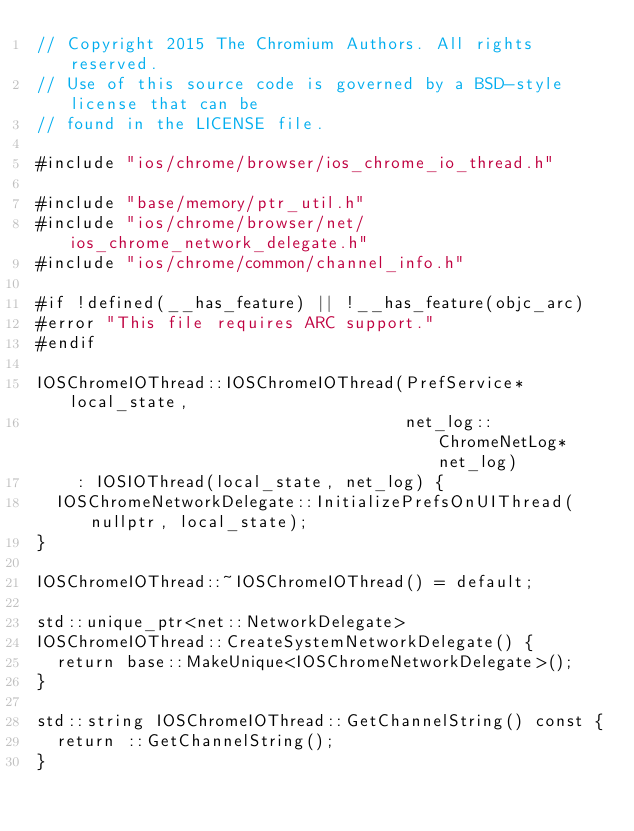<code> <loc_0><loc_0><loc_500><loc_500><_ObjectiveC_>// Copyright 2015 The Chromium Authors. All rights reserved.
// Use of this source code is governed by a BSD-style license that can be
// found in the LICENSE file.

#include "ios/chrome/browser/ios_chrome_io_thread.h"

#include "base/memory/ptr_util.h"
#include "ios/chrome/browser/net/ios_chrome_network_delegate.h"
#include "ios/chrome/common/channel_info.h"

#if !defined(__has_feature) || !__has_feature(objc_arc)
#error "This file requires ARC support."
#endif

IOSChromeIOThread::IOSChromeIOThread(PrefService* local_state,
                                     net_log::ChromeNetLog* net_log)
    : IOSIOThread(local_state, net_log) {
  IOSChromeNetworkDelegate::InitializePrefsOnUIThread(nullptr, local_state);
}

IOSChromeIOThread::~IOSChromeIOThread() = default;

std::unique_ptr<net::NetworkDelegate>
IOSChromeIOThread::CreateSystemNetworkDelegate() {
  return base::MakeUnique<IOSChromeNetworkDelegate>();
}

std::string IOSChromeIOThread::GetChannelString() const {
  return ::GetChannelString();
}
</code> 